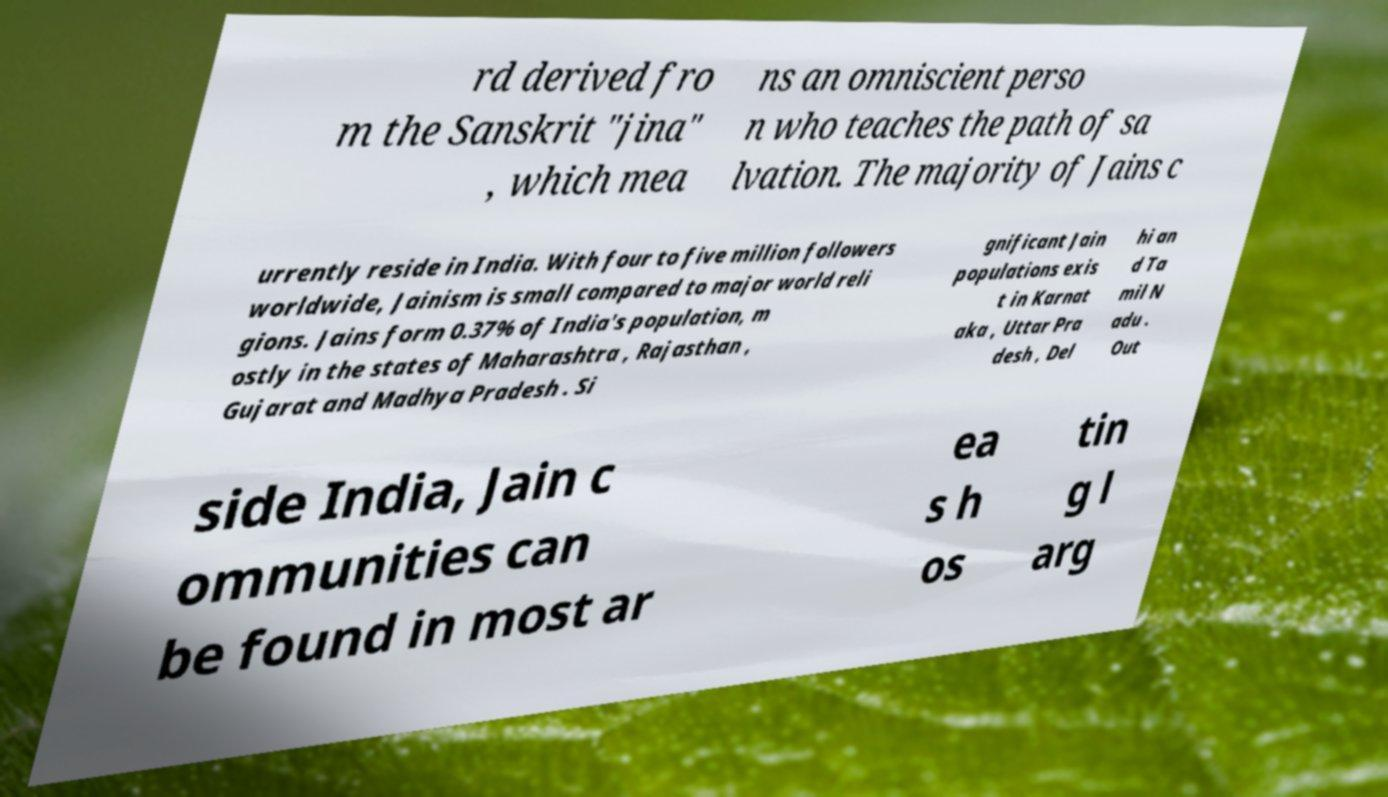Can you accurately transcribe the text from the provided image for me? rd derived fro m the Sanskrit "jina" , which mea ns an omniscient perso n who teaches the path of sa lvation. The majority of Jains c urrently reside in India. With four to five million followers worldwide, Jainism is small compared to major world reli gions. Jains form 0.37% of India's population, m ostly in the states of Maharashtra , Rajasthan , Gujarat and Madhya Pradesh . Si gnificant Jain populations exis t in Karnat aka , Uttar Pra desh , Del hi an d Ta mil N adu . Out side India, Jain c ommunities can be found in most ar ea s h os tin g l arg 